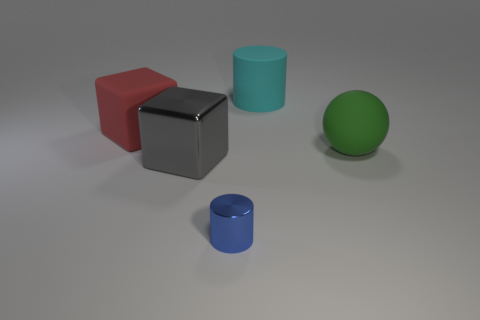What number of things are either cylinders that are in front of the gray shiny object or matte things that are left of the big green matte object?
Make the answer very short. 3. Is there anything else that has the same shape as the green rubber thing?
Ensure brevity in your answer.  No. There is a shiny object to the left of the tiny blue cylinder; is its color the same as the large thing left of the large metallic cube?
Your response must be concise. No. How many shiny things are brown balls or green objects?
Your response must be concise. 0. Is there anything else that is the same size as the red matte thing?
Your answer should be very brief. Yes. There is a big matte thing that is to the left of the block in front of the large green thing; what is its shape?
Give a very brief answer. Cube. Is the material of the big thing on the right side of the cyan matte thing the same as the large object in front of the green rubber object?
Provide a short and direct response. No. How many matte things are to the left of the big thing to the right of the big matte cylinder?
Your response must be concise. 2. There is a rubber thing in front of the red matte cube; does it have the same shape as the thing to the left of the shiny block?
Keep it short and to the point. No. How big is the thing that is right of the blue thing and in front of the large rubber cube?
Offer a very short reply. Large. 